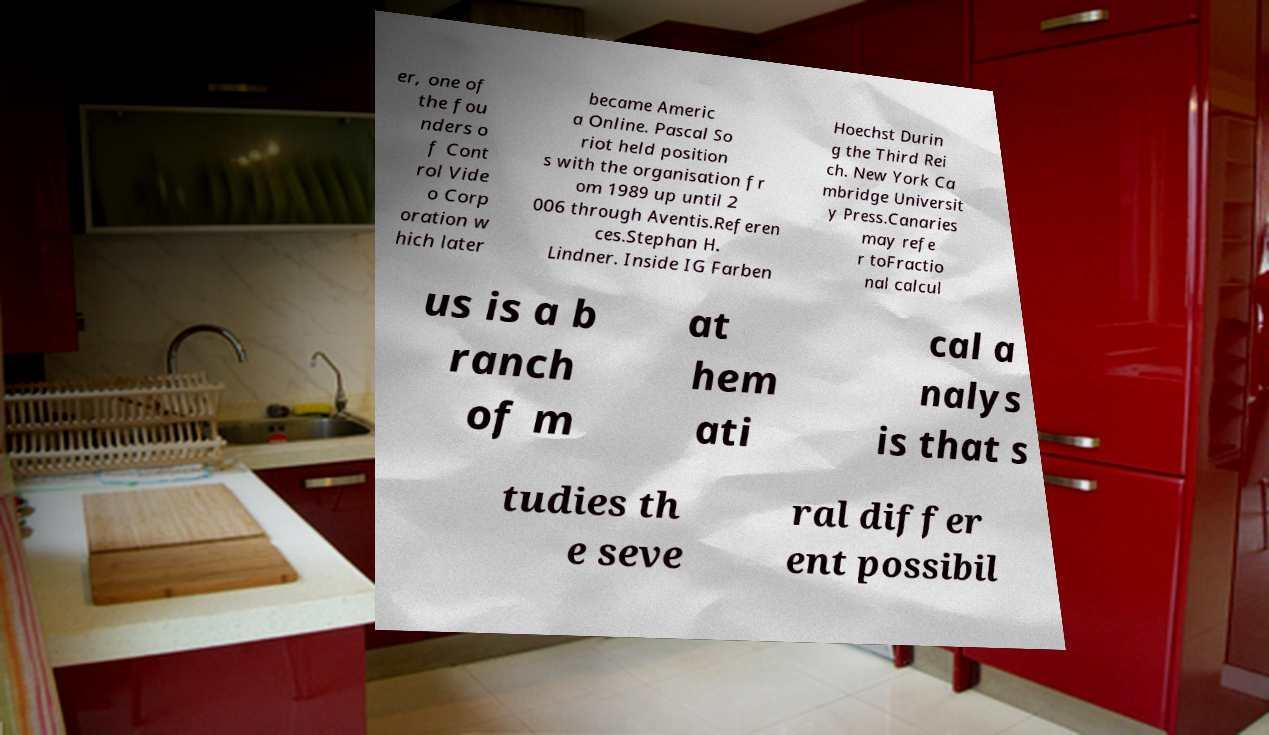Can you accurately transcribe the text from the provided image for me? er, one of the fou nders o f Cont rol Vide o Corp oration w hich later became Americ a Online. Pascal So riot held position s with the organisation fr om 1989 up until 2 006 through Aventis.Referen ces.Stephan H. Lindner. Inside IG Farben Hoechst Durin g the Third Rei ch. New York Ca mbridge Universit y Press.Canaries may refe r toFractio nal calcul us is a b ranch of m at hem ati cal a nalys is that s tudies th e seve ral differ ent possibil 